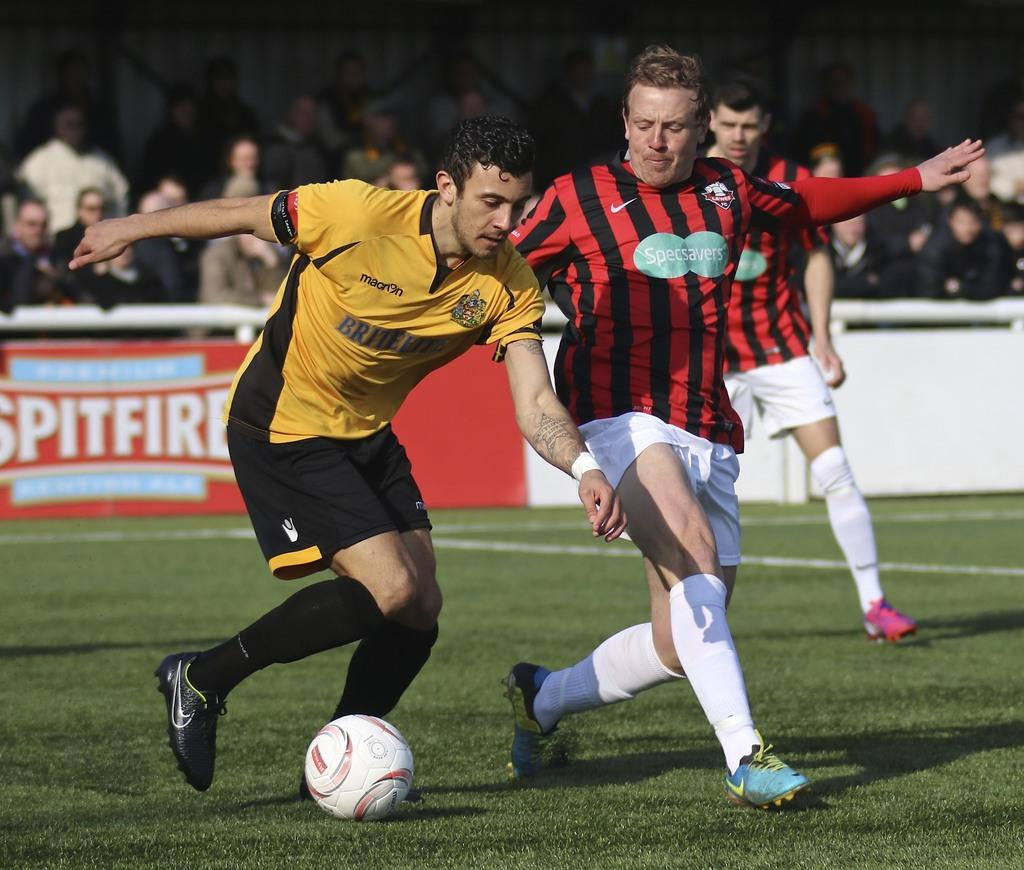What type of vegetation can be seen in the image? There is grass in the image. What is the color of the wall visible in the image? There is a white color wall in the image. What is hanging or attached to the wall in the image? There is a banner in the image. Can you describe the people in the image? There is a group of people in the image. What type of iron can be seen in the image? There is no iron present in the image. Can you describe the cow grazing in the grass in the image? There is no cow present in the image; it only features grass and a group of people. 